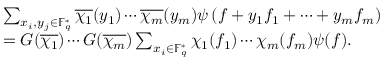Convert formula to latex. <formula><loc_0><loc_0><loc_500><loc_500>\begin{array} { r l } & { \sum _ { x _ { i } , y _ { j } \in \mathbb { F } _ { q } ^ { * } } \overline { { \chi _ { 1 } } } ( y _ { 1 } ) \cdots \overline { { \chi _ { m } } } ( y _ { m } ) \psi \left ( f + y _ { 1 } f _ { 1 } + \cdots + y _ { m } f _ { m } \right ) } \\ & { = G ( \overline { { \chi _ { 1 } } } ) \cdots G ( \overline { { \chi _ { m } } } ) \sum _ { x _ { i } \in \mathbb { F } _ { q } ^ { * } } \chi _ { 1 } ( f _ { 1 } ) \cdots \chi _ { m } ( f _ { m } ) \psi ( f ) . } \end{array}</formula> 